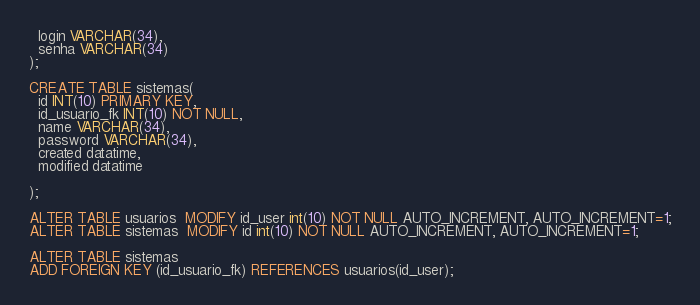Convert code to text. <code><loc_0><loc_0><loc_500><loc_500><_SQL_>  login VARCHAR(34),
  senha VARCHAR(34)
);

CREATE TABLE sistemas(
  id INT(10) PRIMARY KEY,
  id_usuario_fk INT(10) NOT NULL,
  name VARCHAR(34),
  password VARCHAR(34),
  created datatime,
  modified datatime

);

ALTER TABLE usuarios  MODIFY id_user int(10) NOT NULL AUTO_INCREMENT, AUTO_INCREMENT=1;
ALTER TABLE sistemas  MODIFY id int(10) NOT NULL AUTO_INCREMENT, AUTO_INCREMENT=1;

ALTER TABLE sistemas
ADD FOREIGN KEY (id_usuario_fk) REFERENCES usuarios(id_user);
</code> 